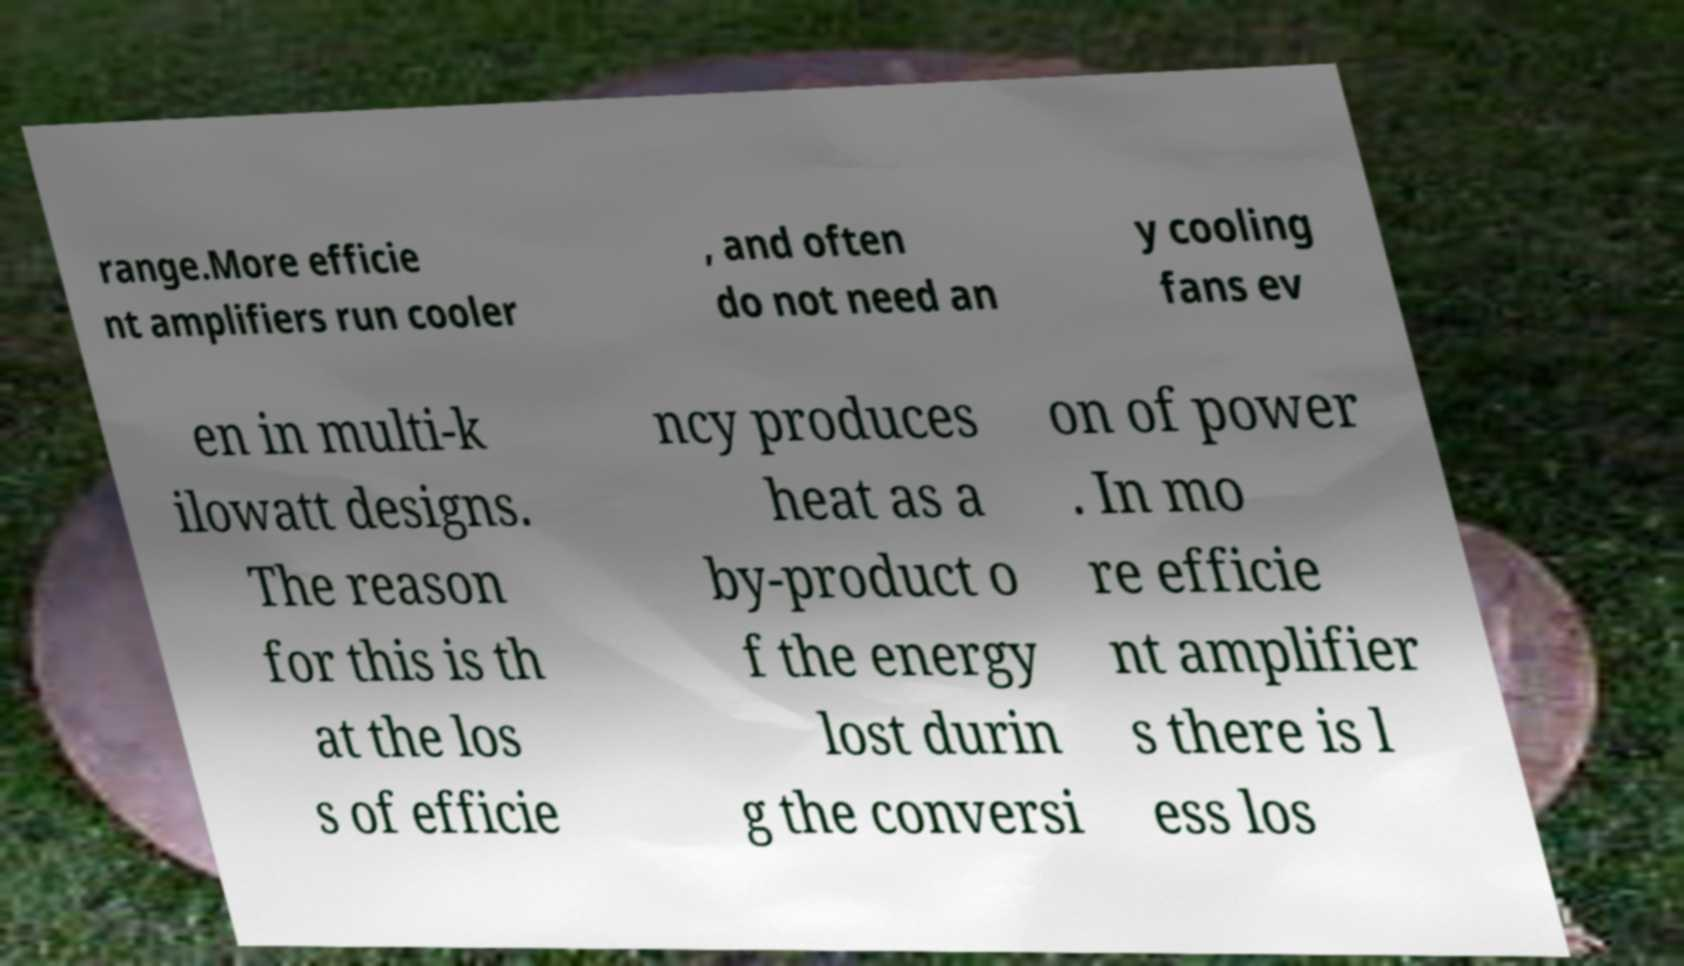For documentation purposes, I need the text within this image transcribed. Could you provide that? range.More efficie nt amplifiers run cooler , and often do not need an y cooling fans ev en in multi-k ilowatt designs. The reason for this is th at the los s of efficie ncy produces heat as a by-product o f the energy lost durin g the conversi on of power . In mo re efficie nt amplifier s there is l ess los 